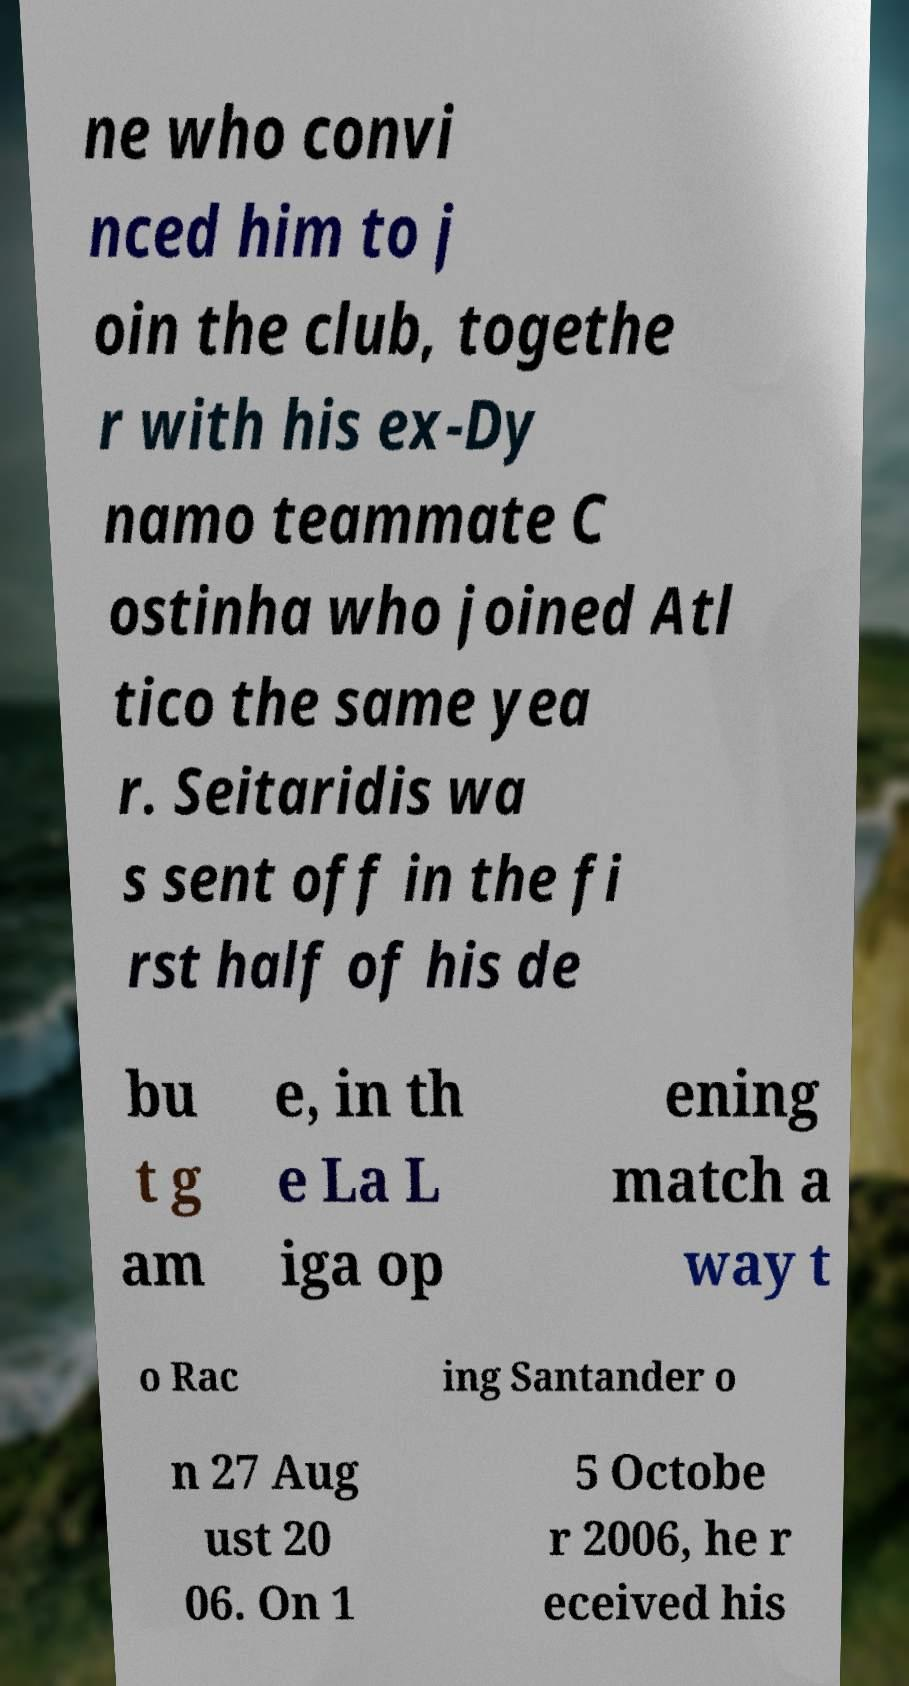Please identify and transcribe the text found in this image. ne who convi nced him to j oin the club, togethe r with his ex-Dy namo teammate C ostinha who joined Atl tico the same yea r. Seitaridis wa s sent off in the fi rst half of his de bu t g am e, in th e La L iga op ening match a way t o Rac ing Santander o n 27 Aug ust 20 06. On 1 5 Octobe r 2006, he r eceived his 